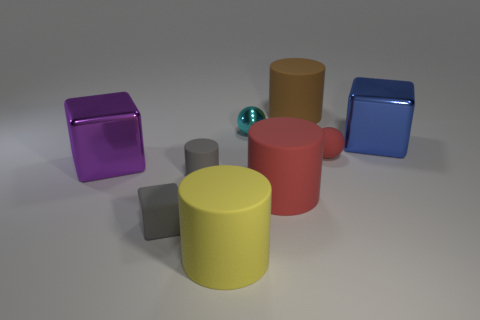Subtract all purple blocks. How many blocks are left? 2 Subtract all gray blocks. How many blocks are left? 2 Subtract all blocks. How many objects are left? 6 Subtract all yellow spheres. How many gray cubes are left? 1 Add 6 big red matte objects. How many big red matte objects are left? 7 Add 8 tiny blocks. How many tiny blocks exist? 9 Subtract 1 gray cylinders. How many objects are left? 8 Subtract 2 cylinders. How many cylinders are left? 2 Subtract all green blocks. Subtract all red spheres. How many blocks are left? 3 Subtract all tiny cylinders. Subtract all big purple cylinders. How many objects are left? 8 